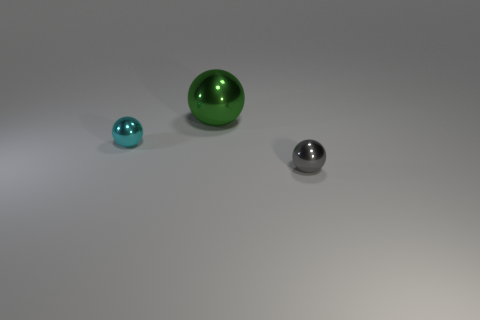What is the shape of the tiny gray thing? The tiny gray object in the image has a spherical shape, showcasing a smooth and symmetrical surface that reflects light, giving it a reflective sheen that is typical of spheres. 